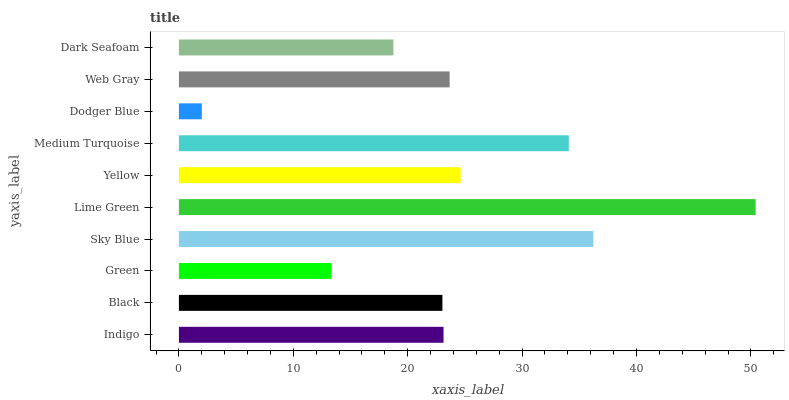Is Dodger Blue the minimum?
Answer yes or no. Yes. Is Lime Green the maximum?
Answer yes or no. Yes. Is Black the minimum?
Answer yes or no. No. Is Black the maximum?
Answer yes or no. No. Is Indigo greater than Black?
Answer yes or no. Yes. Is Black less than Indigo?
Answer yes or no. Yes. Is Black greater than Indigo?
Answer yes or no. No. Is Indigo less than Black?
Answer yes or no. No. Is Web Gray the high median?
Answer yes or no. Yes. Is Indigo the low median?
Answer yes or no. Yes. Is Black the high median?
Answer yes or no. No. Is Dark Seafoam the low median?
Answer yes or no. No. 